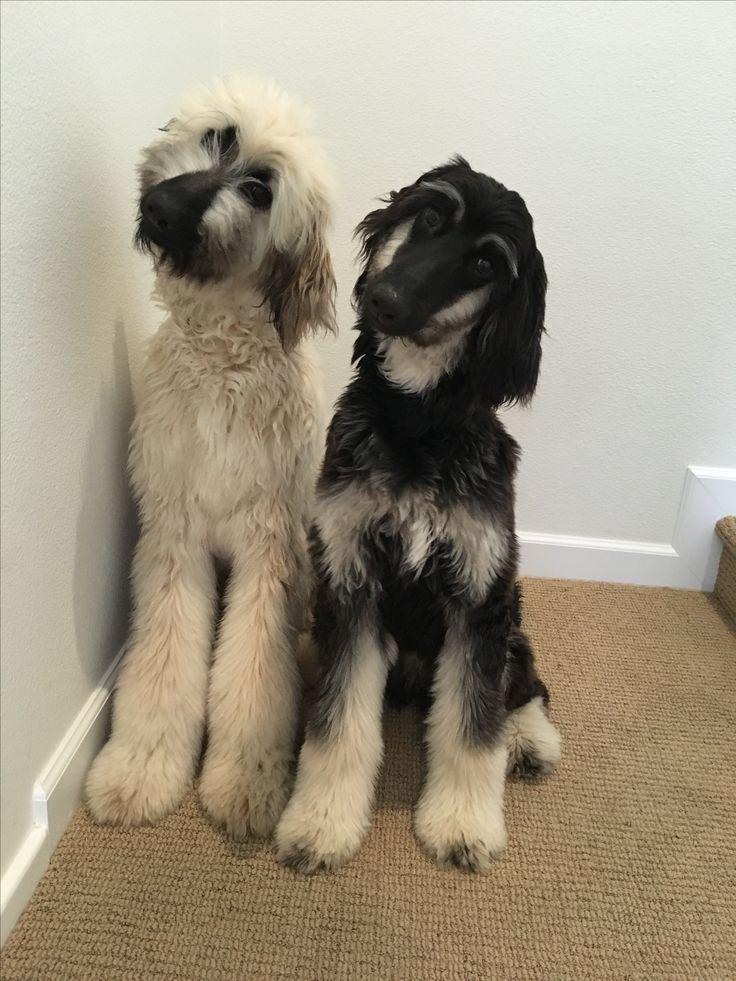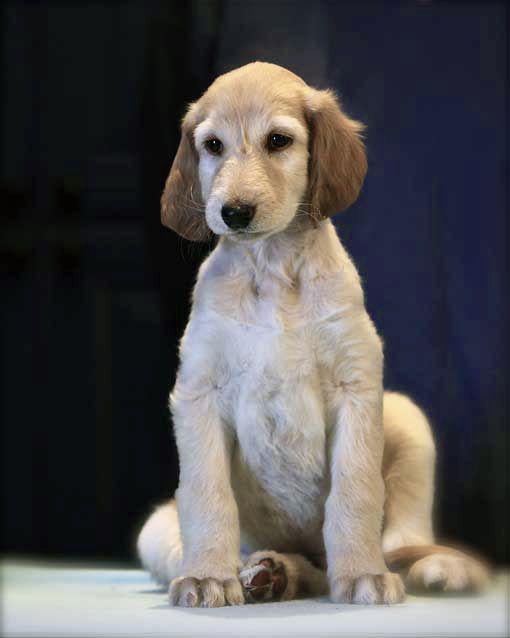The first image is the image on the left, the second image is the image on the right. Analyze the images presented: Is the assertion "Each image contains a single afghan hound, no hound is primarily black, and the hound on the left has its curled orange tail visible." valid? Answer yes or no. No. 